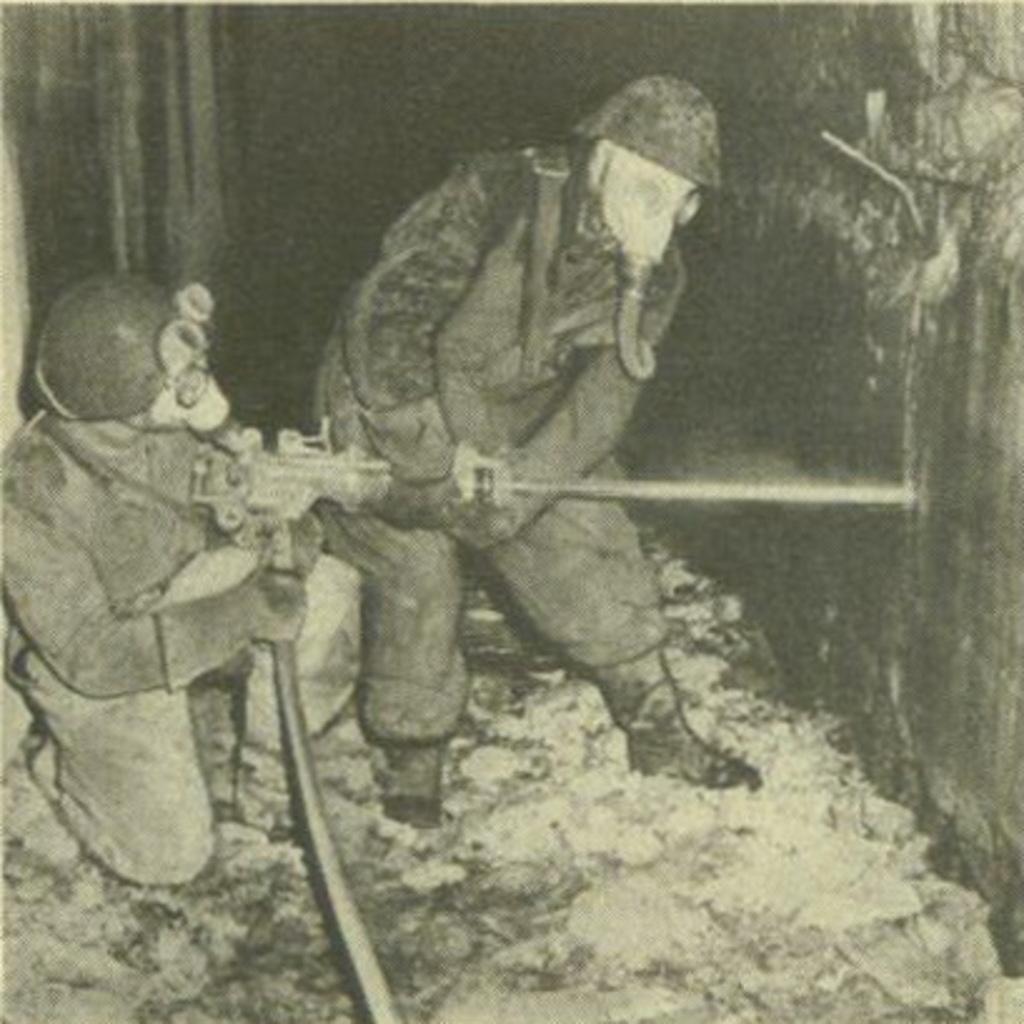Can you describe this image briefly? In this picture we can see two men, they are holding a machine and they wore masks. 